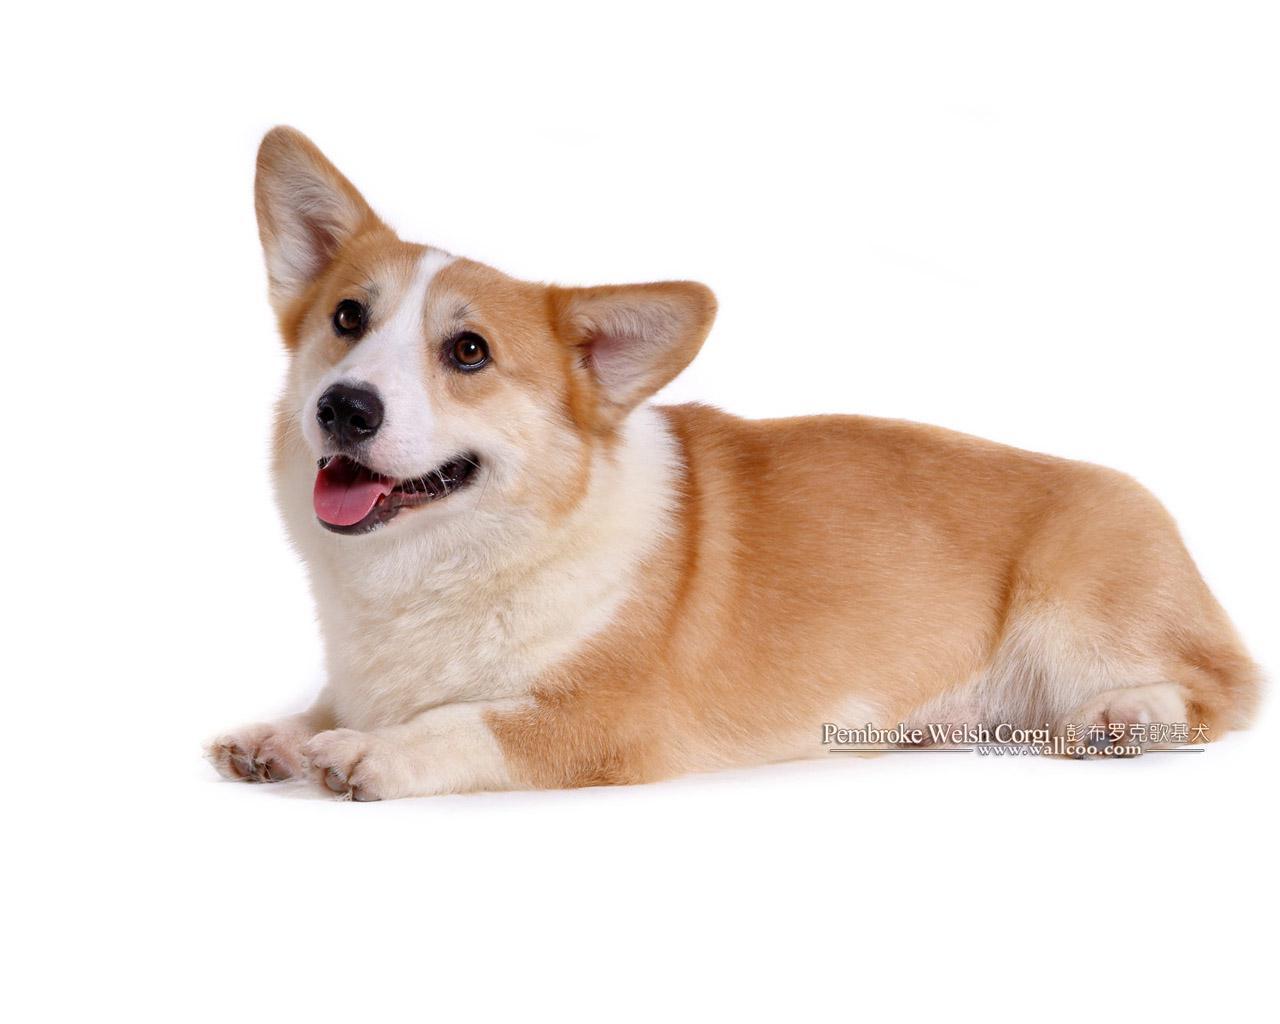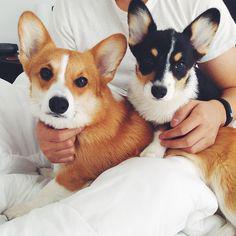The first image is the image on the left, the second image is the image on the right. Analyze the images presented: Is the assertion "One image shows a pair of camera-facing dogs with their heads next to one another." valid? Answer yes or no. Yes. The first image is the image on the left, the second image is the image on the right. For the images displayed, is the sentence "The right image contains exactly two dogs." factually correct? Answer yes or no. Yes. 